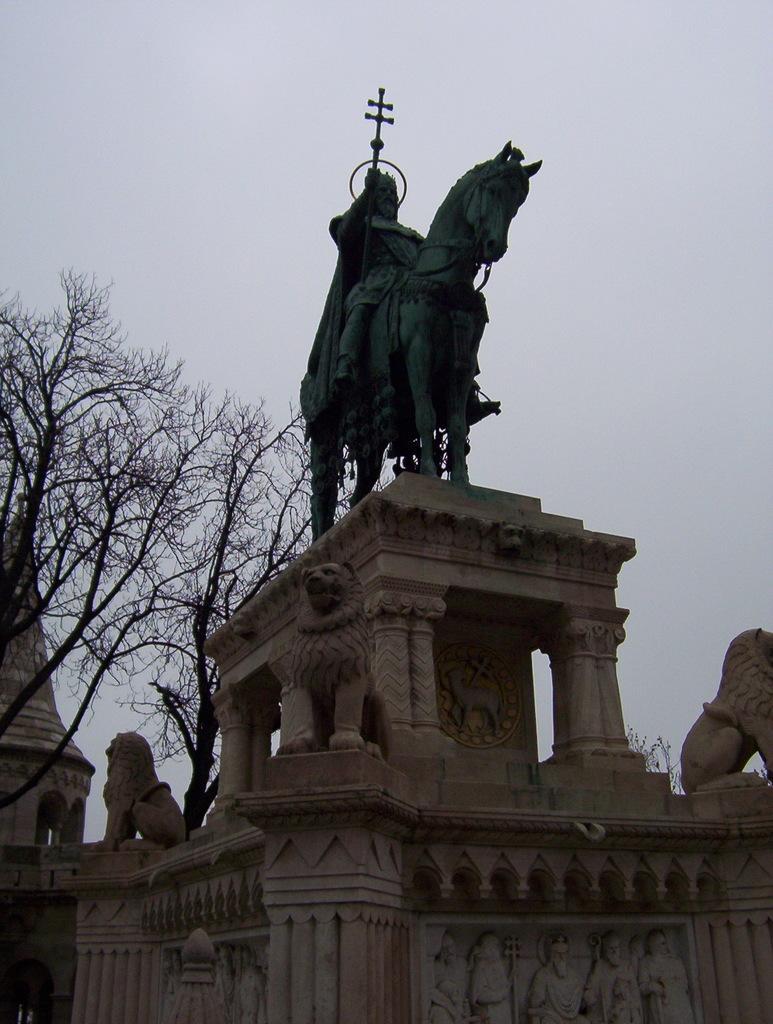How would you summarize this image in a sentence or two? In the picture we can see a historical construction with some sculptures to it and on the top of it, we can see a statue of a man sitting on the horse which is black in color and behind it we can see two dried trees and a sky. 